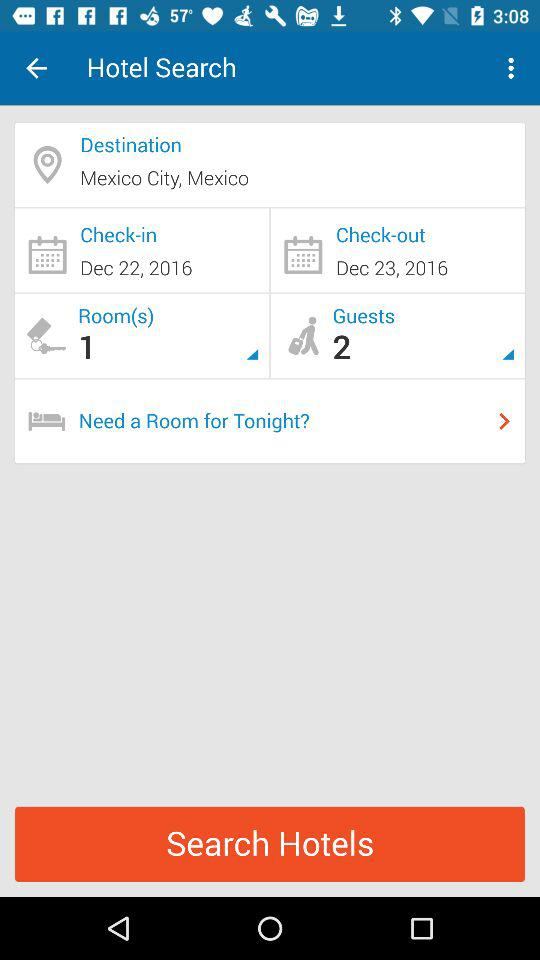How many days are between the check-in and check-out dates?
Answer the question using a single word or phrase. 1 